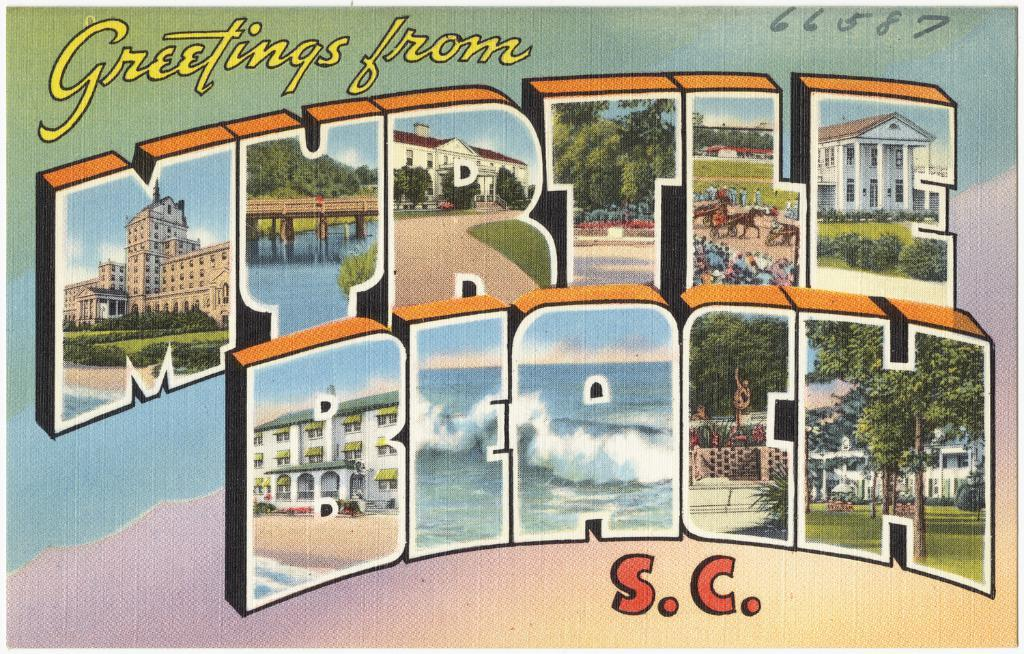What is the main subject of the image? There is a painting in the image. What else can be seen in the painting? There is writing, buildings, trees, people, a statue, and an ocean in the image. Can you describe the setting of the painting? The painting features a combination of natural and man-made elements, including trees, buildings, and an ocean. Are there any human-made structures visible in the image? Yes, there are buildings and a statue visible in the image. What type of skirt is the ocean wearing in the image? The ocean is not wearing a skirt in the image, as it is a natural body of water and not a person. 